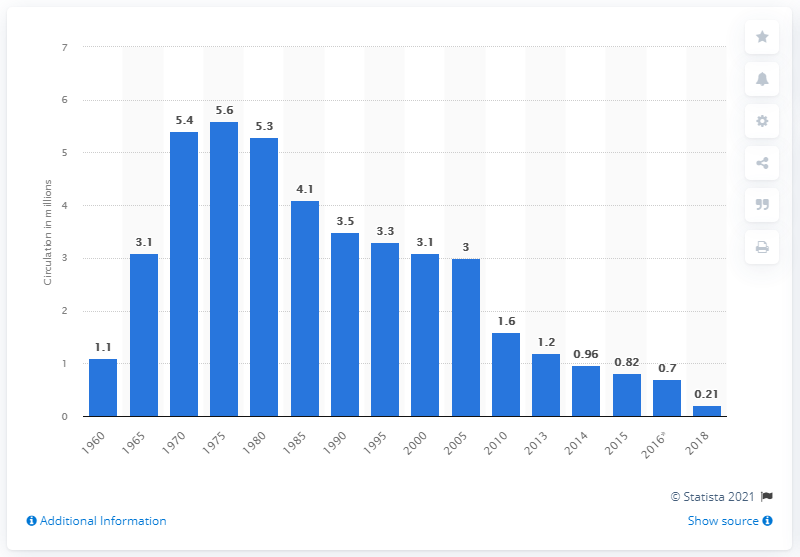Give some essential details in this illustration. Playboy had 1.2 copies five years earlier. I am not sure what you are trying to ask. Could you please rephrase or provide more context? In 1975, Playboy had its highest global circulation. In 1975, the average issue of Playboy sold approximately 5.6 copies. 